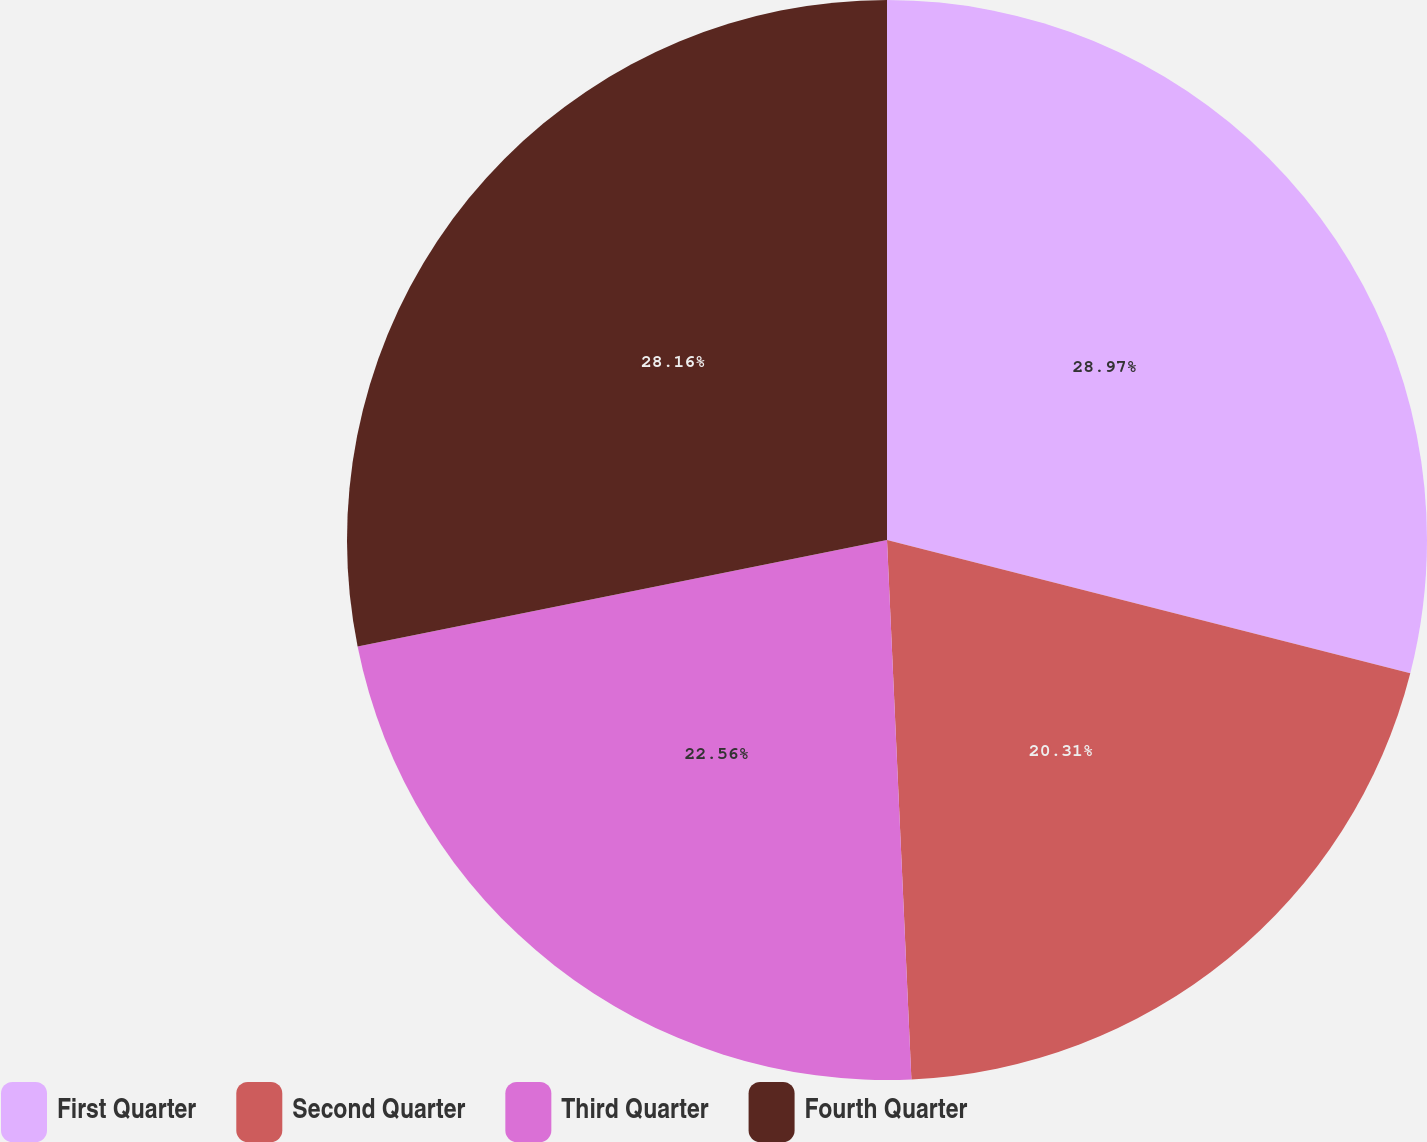Convert chart to OTSL. <chart><loc_0><loc_0><loc_500><loc_500><pie_chart><fcel>First Quarter<fcel>Second Quarter<fcel>Third Quarter<fcel>Fourth Quarter<nl><fcel>28.97%<fcel>20.31%<fcel>22.56%<fcel>28.16%<nl></chart> 